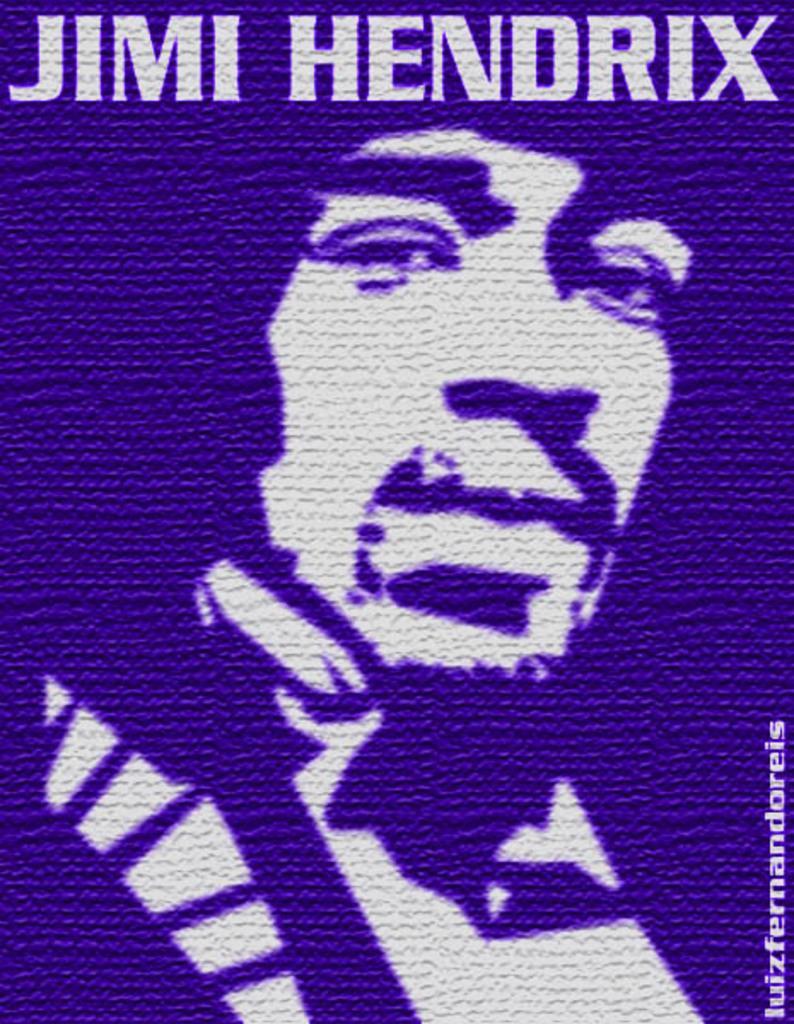In one or two sentences, can you explain what this image depicts? This picture shows a man and we see text on the top of the picture and at the right bottom., 